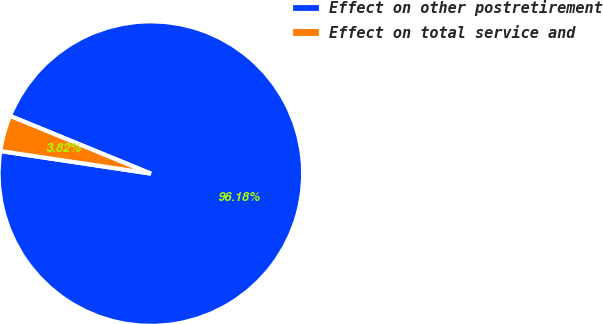Convert chart. <chart><loc_0><loc_0><loc_500><loc_500><pie_chart><fcel>Effect on other postretirement<fcel>Effect on total service and<nl><fcel>96.18%<fcel>3.82%<nl></chart> 